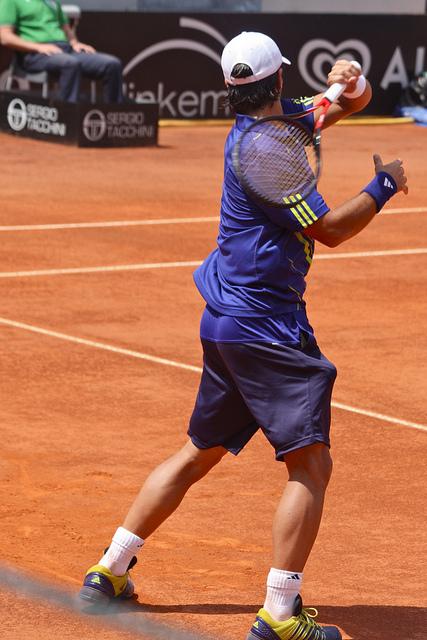What is in the man's hand?
Keep it brief. Tennis racket. What sport is this?
Give a very brief answer. Tennis. Does the many have something in his pocket?
Be succinct. Yes. 